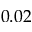Convert formula to latex. <formula><loc_0><loc_0><loc_500><loc_500>0 . 0 2</formula> 